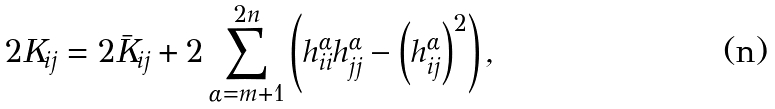Convert formula to latex. <formula><loc_0><loc_0><loc_500><loc_500>2 K _ { i j } = 2 \bar { K } _ { i j } + 2 \sum _ { \alpha = m + 1 } ^ { 2 n } \left ( h _ { i i } ^ { \alpha } h _ { j j } ^ { \alpha } - \left ( h _ { i j } ^ { \alpha } \right ) ^ { 2 } \right ) ,</formula> 